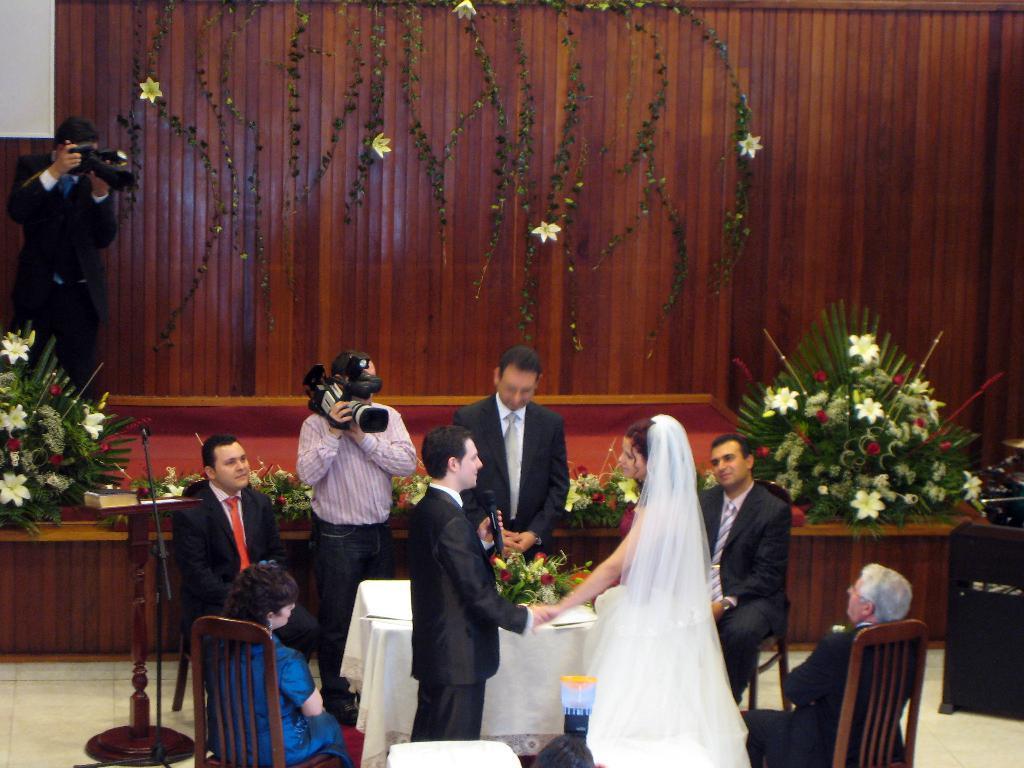In one or two sentences, can you explain what this image depicts? In this image I see few people in which these 4 persons are sitting on chairs and rest of them are standing and I see that these 2 of them are holding cameras and I see a table on which there are flowers. In the background I see the platform on which there are few more flowers on either sides and I see the wooden wall on which there are few more flowers and plants and I see that the flowers are of white in color. 